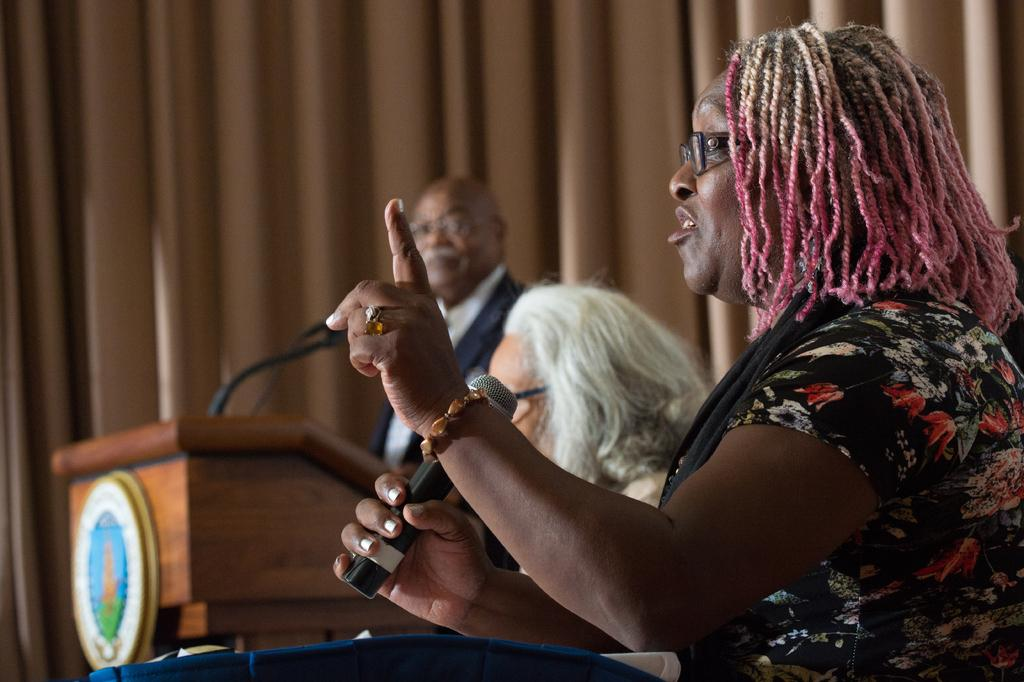What is the man in the image doing? The man in the image is talking. How is the man amplifying his voice in the image? The man is using a microphone. What can be seen on the woman's face in the image? The woman is wearing spectacles. What is the woman wearing in the image? The woman is wearing a dress. What can be seen near the man talking in the image? There is a man standing near a podium. What is present in the background of the image? There is a curtain in the image. What time does the clock in the image show? There is no clock present in the image. What type of sofa can be seen in the image? There is no sofa present in the image. 